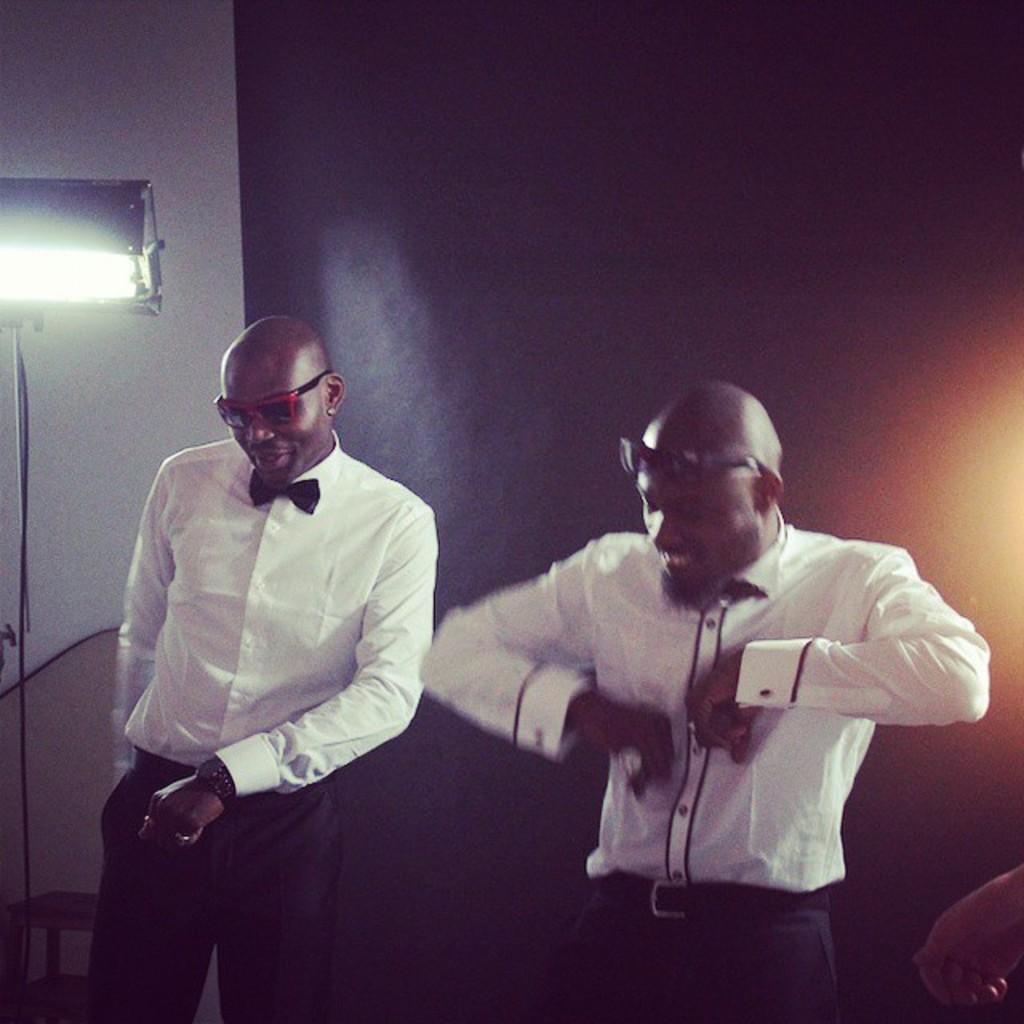In one or two sentences, can you explain what this image depicts? In the picture I can see two persons standing and wearing white shirts and goggles are dancing and there is a light attached to the stand in the left corner and there are some other objects in the background. 